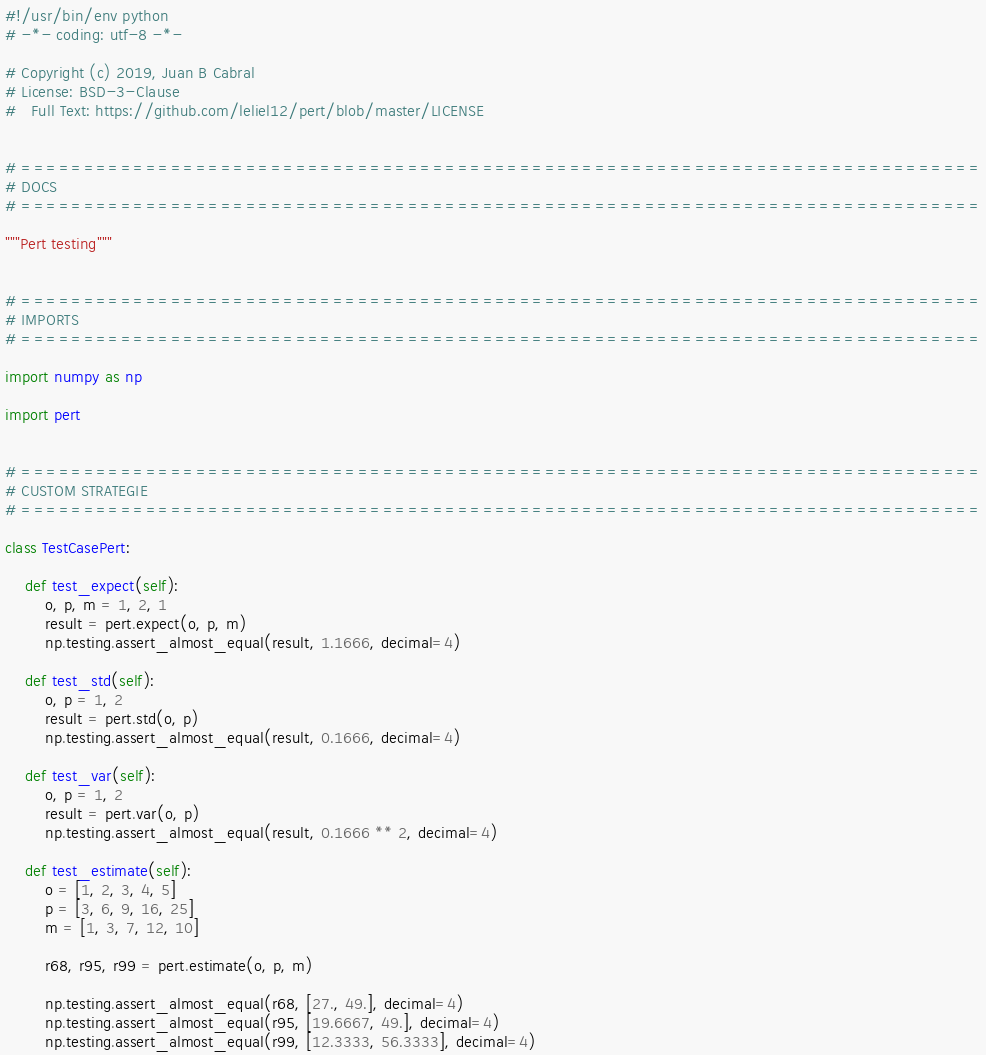Convert code to text. <code><loc_0><loc_0><loc_500><loc_500><_Python_>#!/usr/bin/env python
# -*- coding: utf-8 -*-

# Copyright (c) 2019, Juan B Cabral
# License: BSD-3-Clause
#   Full Text: https://github.com/leliel12/pert/blob/master/LICENSE


# =============================================================================
# DOCS
# =============================================================================

"""Pert testing"""


# =============================================================================
# IMPORTS
# =============================================================================

import numpy as np

import pert


# =============================================================================
# CUSTOM STRATEGIE
# =============================================================================

class TestCasePert:

    def test_expect(self):
        o, p, m = 1, 2, 1
        result = pert.expect(o, p, m)
        np.testing.assert_almost_equal(result, 1.1666, decimal=4)

    def test_std(self):
        o, p = 1, 2
        result = pert.std(o, p)
        np.testing.assert_almost_equal(result, 0.1666, decimal=4)

    def test_var(self):
        o, p = 1, 2
        result = pert.var(o, p)
        np.testing.assert_almost_equal(result, 0.1666 ** 2, decimal=4)

    def test_estimate(self):
        o = [1, 2, 3, 4, 5]
        p = [3, 6, 9, 16, 25]
        m = [1, 3, 7, 12, 10]

        r68, r95, r99 = pert.estimate(o, p, m)

        np.testing.assert_almost_equal(r68, [27., 49.], decimal=4)
        np.testing.assert_almost_equal(r95, [19.6667, 49.], decimal=4)
        np.testing.assert_almost_equal(r99, [12.3333, 56.3333], decimal=4)
</code> 